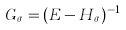Convert formula to latex. <formula><loc_0><loc_0><loc_500><loc_500>G _ { \sigma } = ( E - H _ { \sigma } ) ^ { - 1 }</formula> 